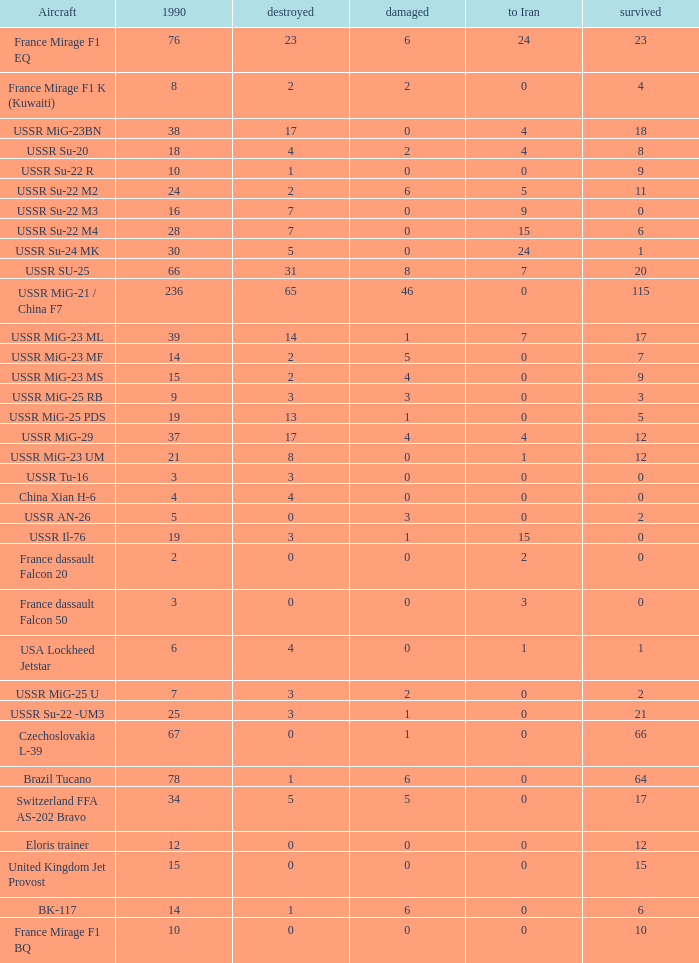0, what was the total in 1990? 1.0. 